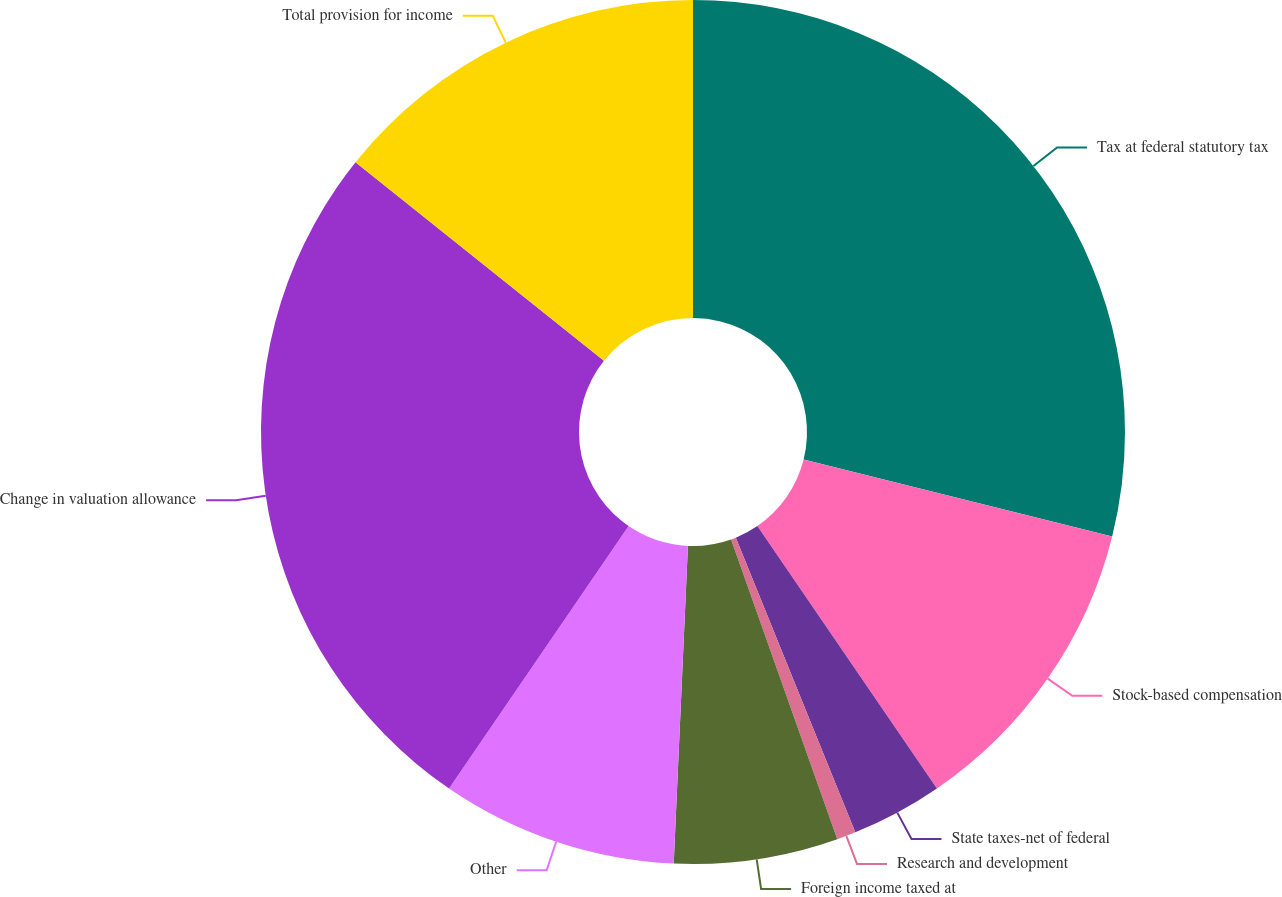Convert chart to OTSL. <chart><loc_0><loc_0><loc_500><loc_500><pie_chart><fcel>Tax at federal statutory tax<fcel>Stock-based compensation<fcel>State taxes-net of federal<fcel>Research and development<fcel>Foreign income taxed at<fcel>Other<fcel>Change in valuation allowance<fcel>Total provision for income<nl><fcel>28.89%<fcel>11.56%<fcel>3.42%<fcel>0.71%<fcel>6.13%<fcel>8.84%<fcel>26.18%<fcel>14.27%<nl></chart> 